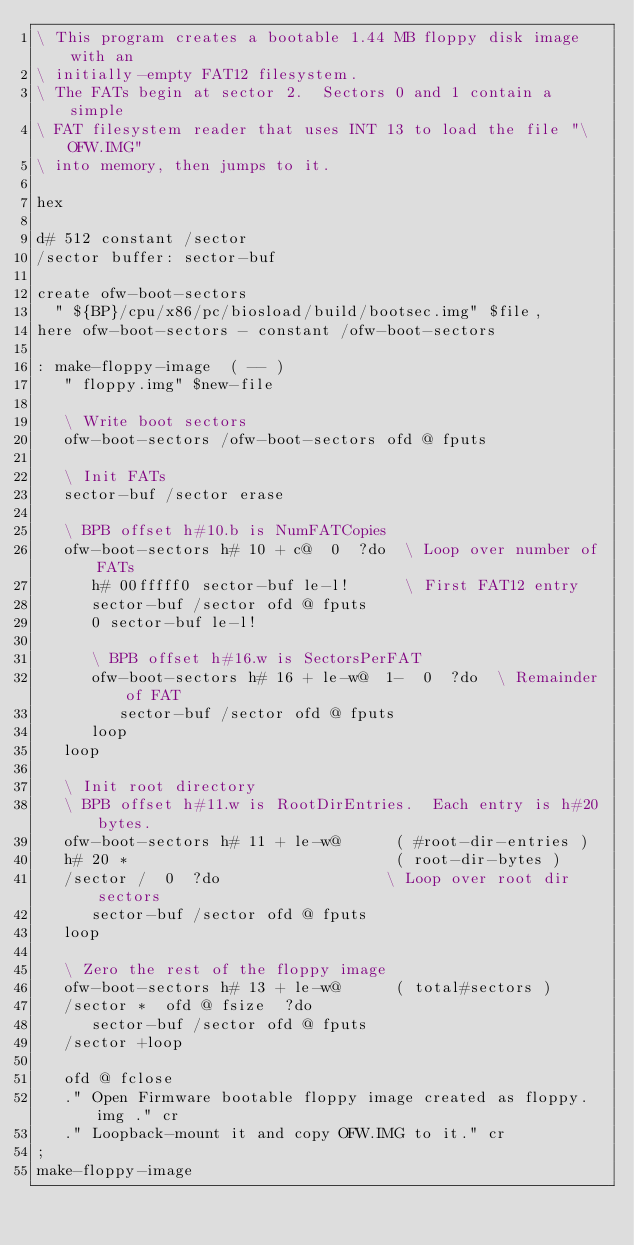<code> <loc_0><loc_0><loc_500><loc_500><_Forth_>\ This program creates a bootable 1.44 MB floppy disk image with an
\ initially-empty FAT12 filesystem.
\ The FATs begin at sector 2.  Sectors 0 and 1 contain a simple
\ FAT filesystem reader that uses INT 13 to load the file "\OFW.IMG"
\ into memory, then jumps to it.

hex

d# 512 constant /sector
/sector buffer: sector-buf

create ofw-boot-sectors
  " ${BP}/cpu/x86/pc/biosload/build/bootsec.img" $file,
here ofw-boot-sectors - constant /ofw-boot-sectors

: make-floppy-image  ( -- )
   " floppy.img" $new-file

   \ Write boot sectors
   ofw-boot-sectors /ofw-boot-sectors ofd @ fputs

   \ Init FATs
   sector-buf /sector erase

   \ BPB offset h#10.b is NumFATCopies
   ofw-boot-sectors h# 10 + c@  0  ?do  \ Loop over number of FATs
      h# 00fffff0 sector-buf le-l!      \ First FAT12 entry
      sector-buf /sector ofd @ fputs
      0 sector-buf le-l!

      \ BPB offset h#16.w is SectorsPerFAT
      ofw-boot-sectors h# 16 + le-w@  1-  0  ?do  \ Remainder of FAT
         sector-buf /sector ofd @ fputs
      loop
   loop

   \ Init root directory
   \ BPB offset h#11.w is RootDirEntries.  Each entry is h#20 bytes.
   ofw-boot-sectors h# 11 + le-w@      ( #root-dir-entries )
   h# 20 *                             ( root-dir-bytes )
   /sector /  0  ?do                  \ Loop over root dir sectors
      sector-buf /sector ofd @ fputs
   loop

   \ Zero the rest of the floppy image
   ofw-boot-sectors h# 13 + le-w@      ( total#sectors )
   /sector *  ofd @ fsize  ?do
      sector-buf /sector ofd @ fputs
   /sector +loop

   ofd @ fclose
   ." Open Firmware bootable floppy image created as floppy.img ." cr
   ." Loopback-mount it and copy OFW.IMG to it." cr
;
make-floppy-image
</code> 